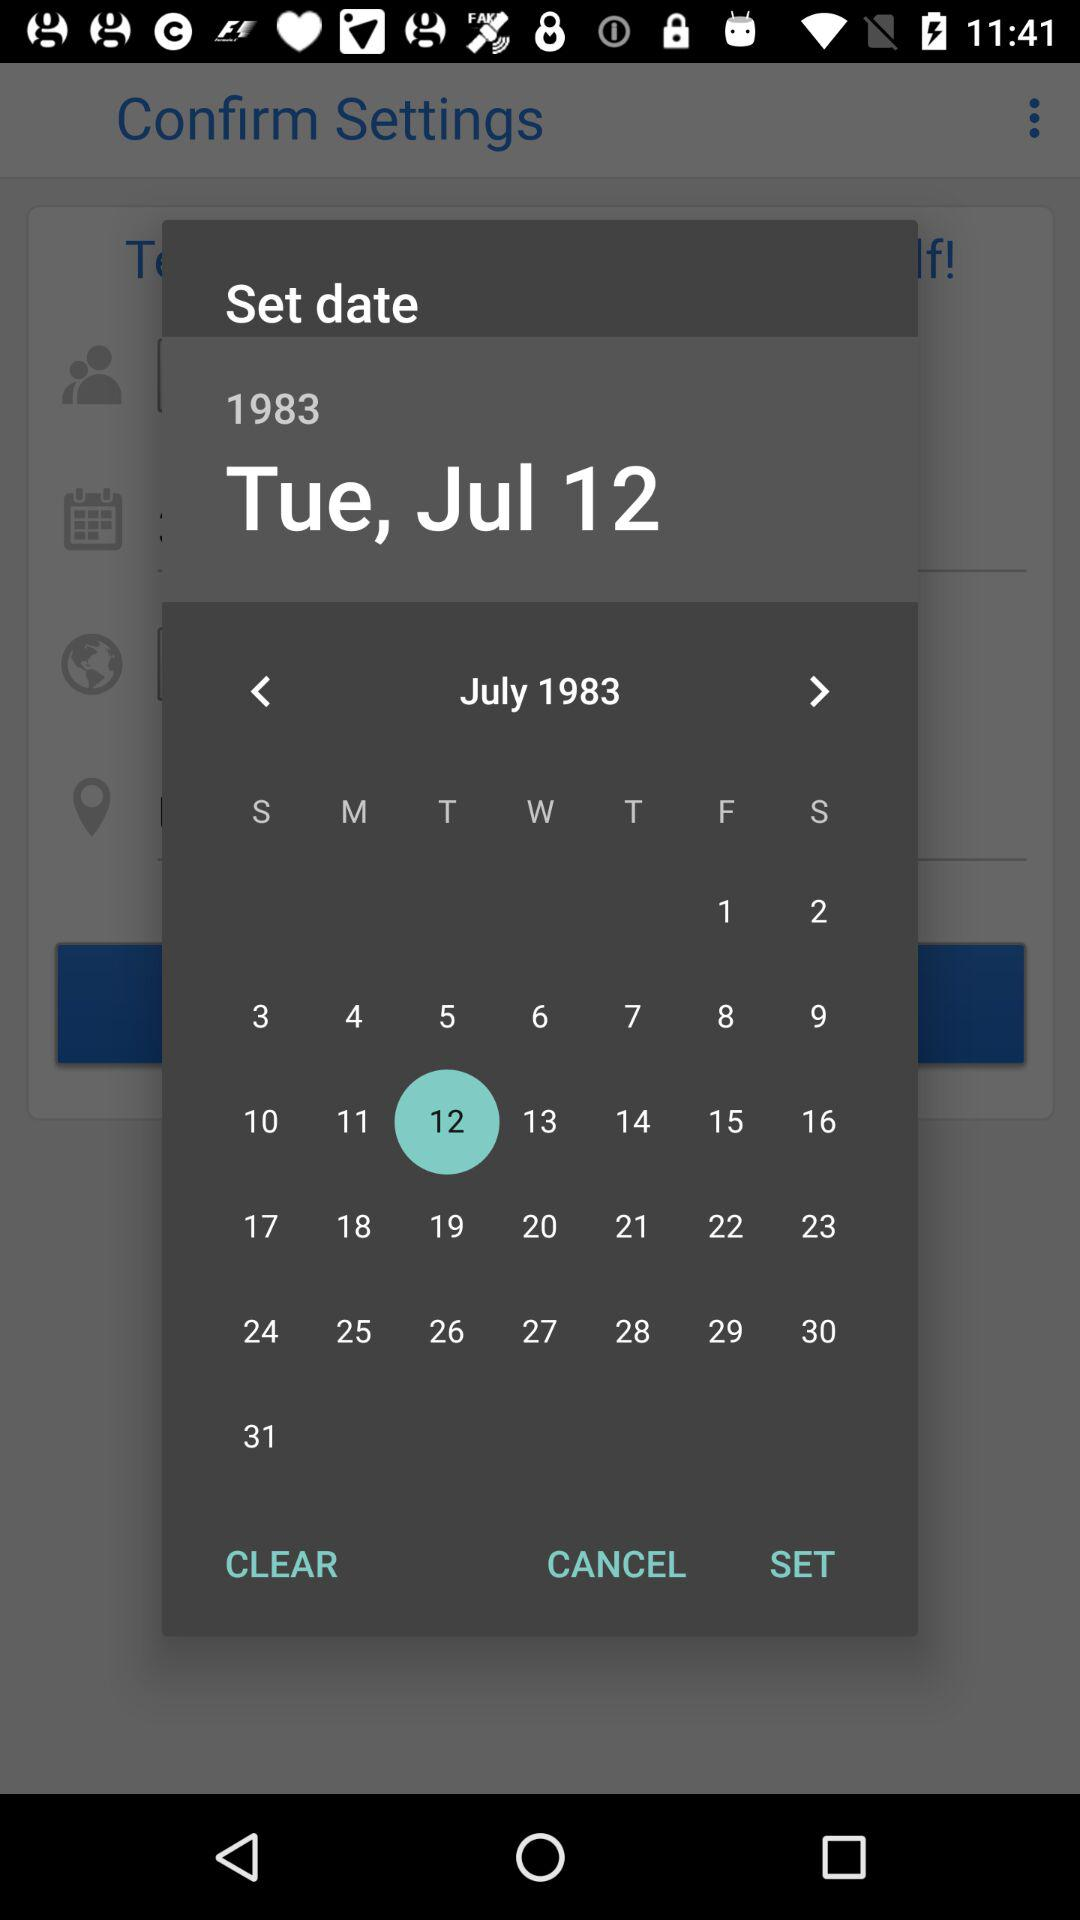What is the day of the week of the selected date?
Answer the question using a single word or phrase. Tuesday 